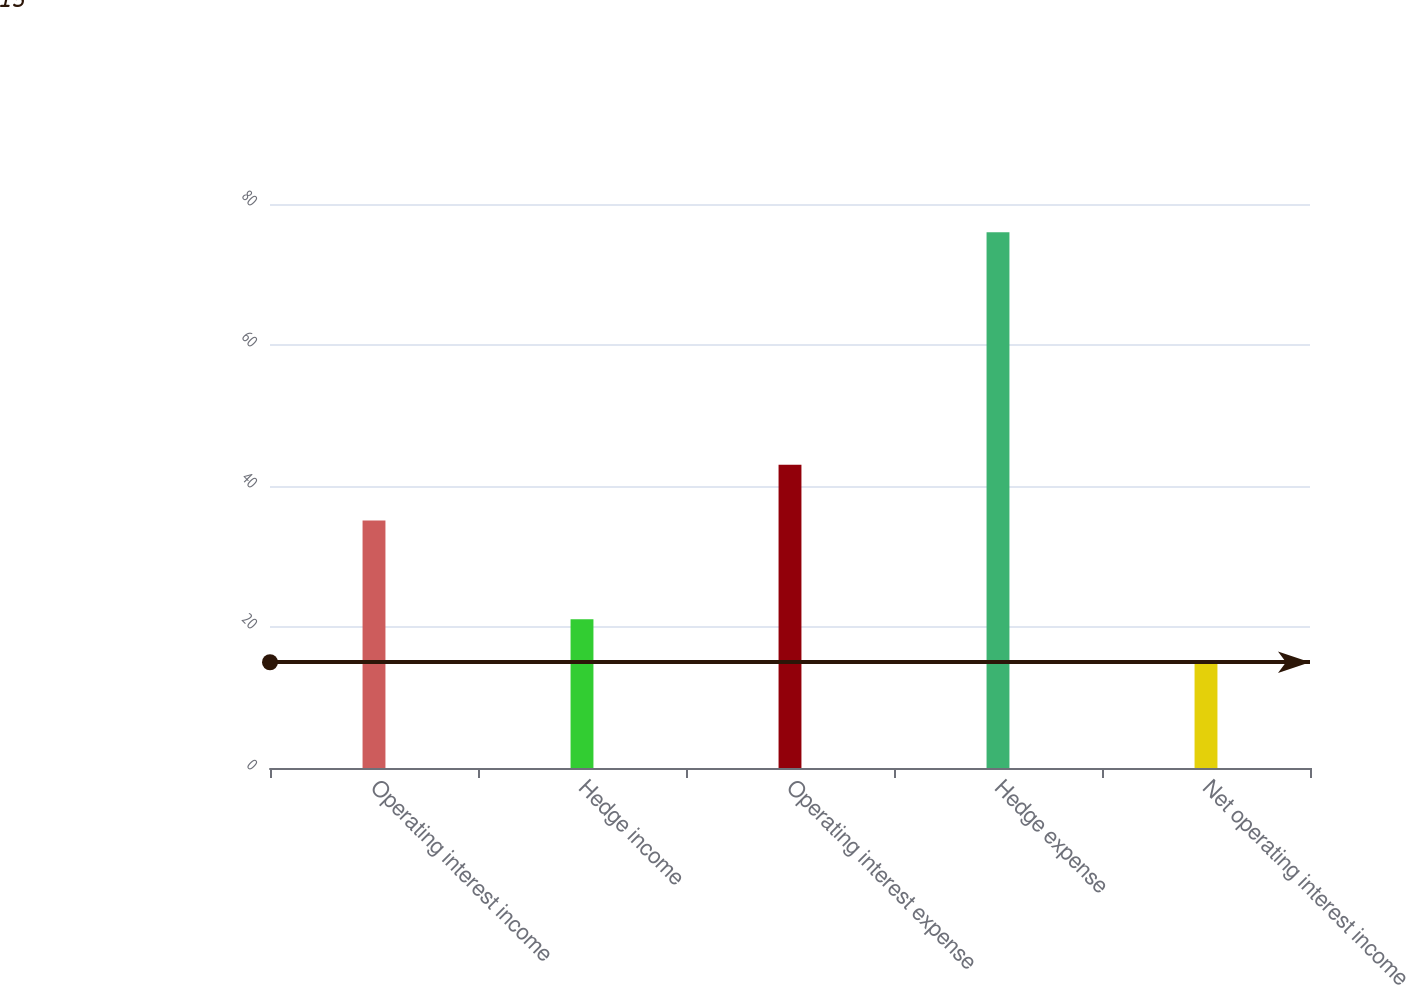<chart> <loc_0><loc_0><loc_500><loc_500><bar_chart><fcel>Operating interest income<fcel>Hedge income<fcel>Operating interest expense<fcel>Hedge expense<fcel>Net operating interest income<nl><fcel>35.1<fcel>21.1<fcel>43<fcel>76<fcel>15<nl></chart> 